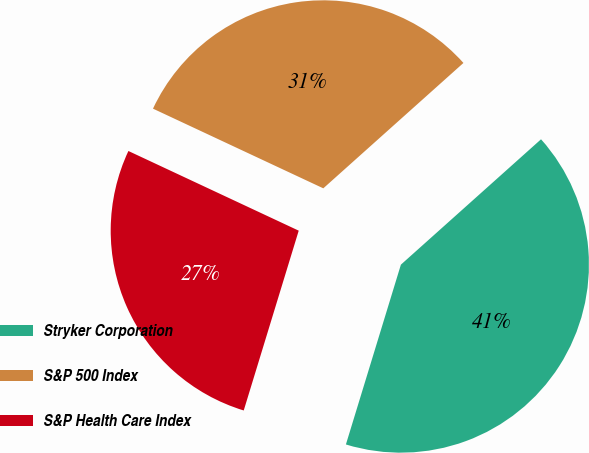Convert chart. <chart><loc_0><loc_0><loc_500><loc_500><pie_chart><fcel>Stryker Corporation<fcel>S&P 500 Index<fcel>S&P Health Care Index<nl><fcel>41.34%<fcel>31.42%<fcel>27.24%<nl></chart> 